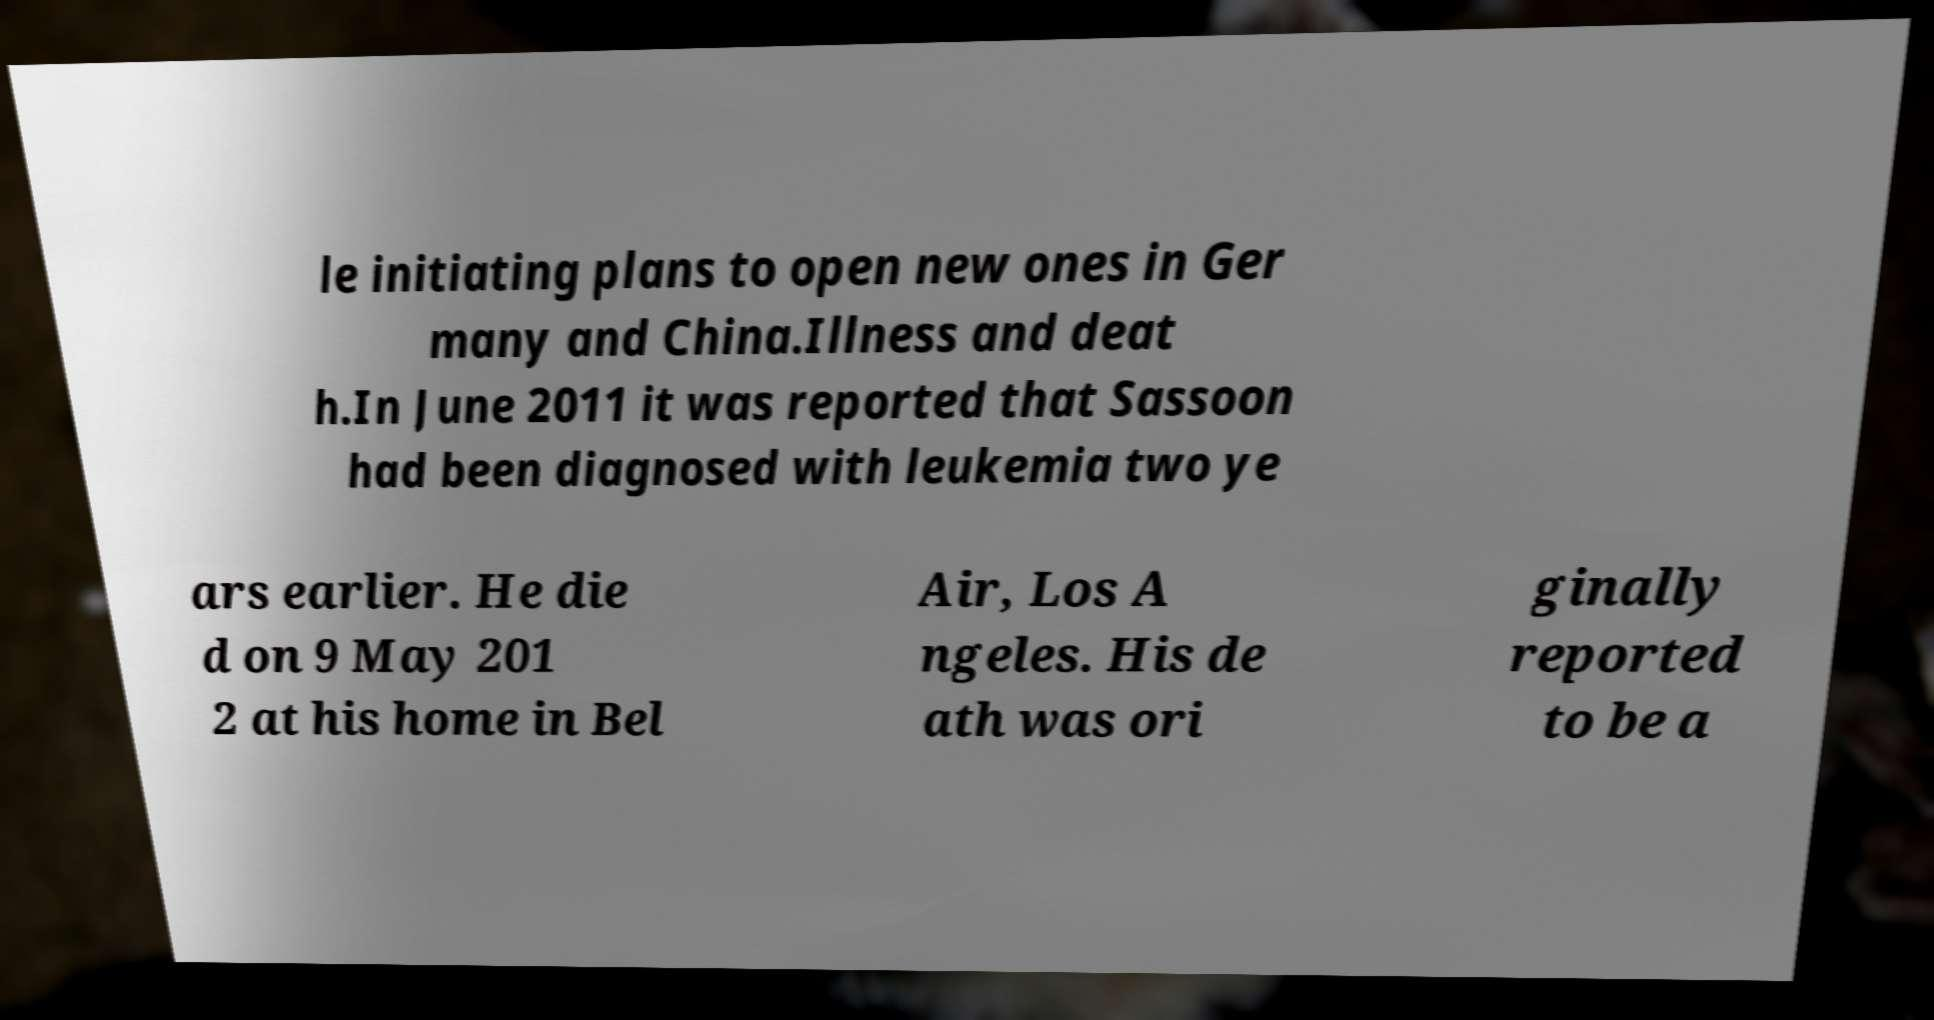Please read and relay the text visible in this image. What does it say? le initiating plans to open new ones in Ger many and China.Illness and deat h.In June 2011 it was reported that Sassoon had been diagnosed with leukemia two ye ars earlier. He die d on 9 May 201 2 at his home in Bel Air, Los A ngeles. His de ath was ori ginally reported to be a 